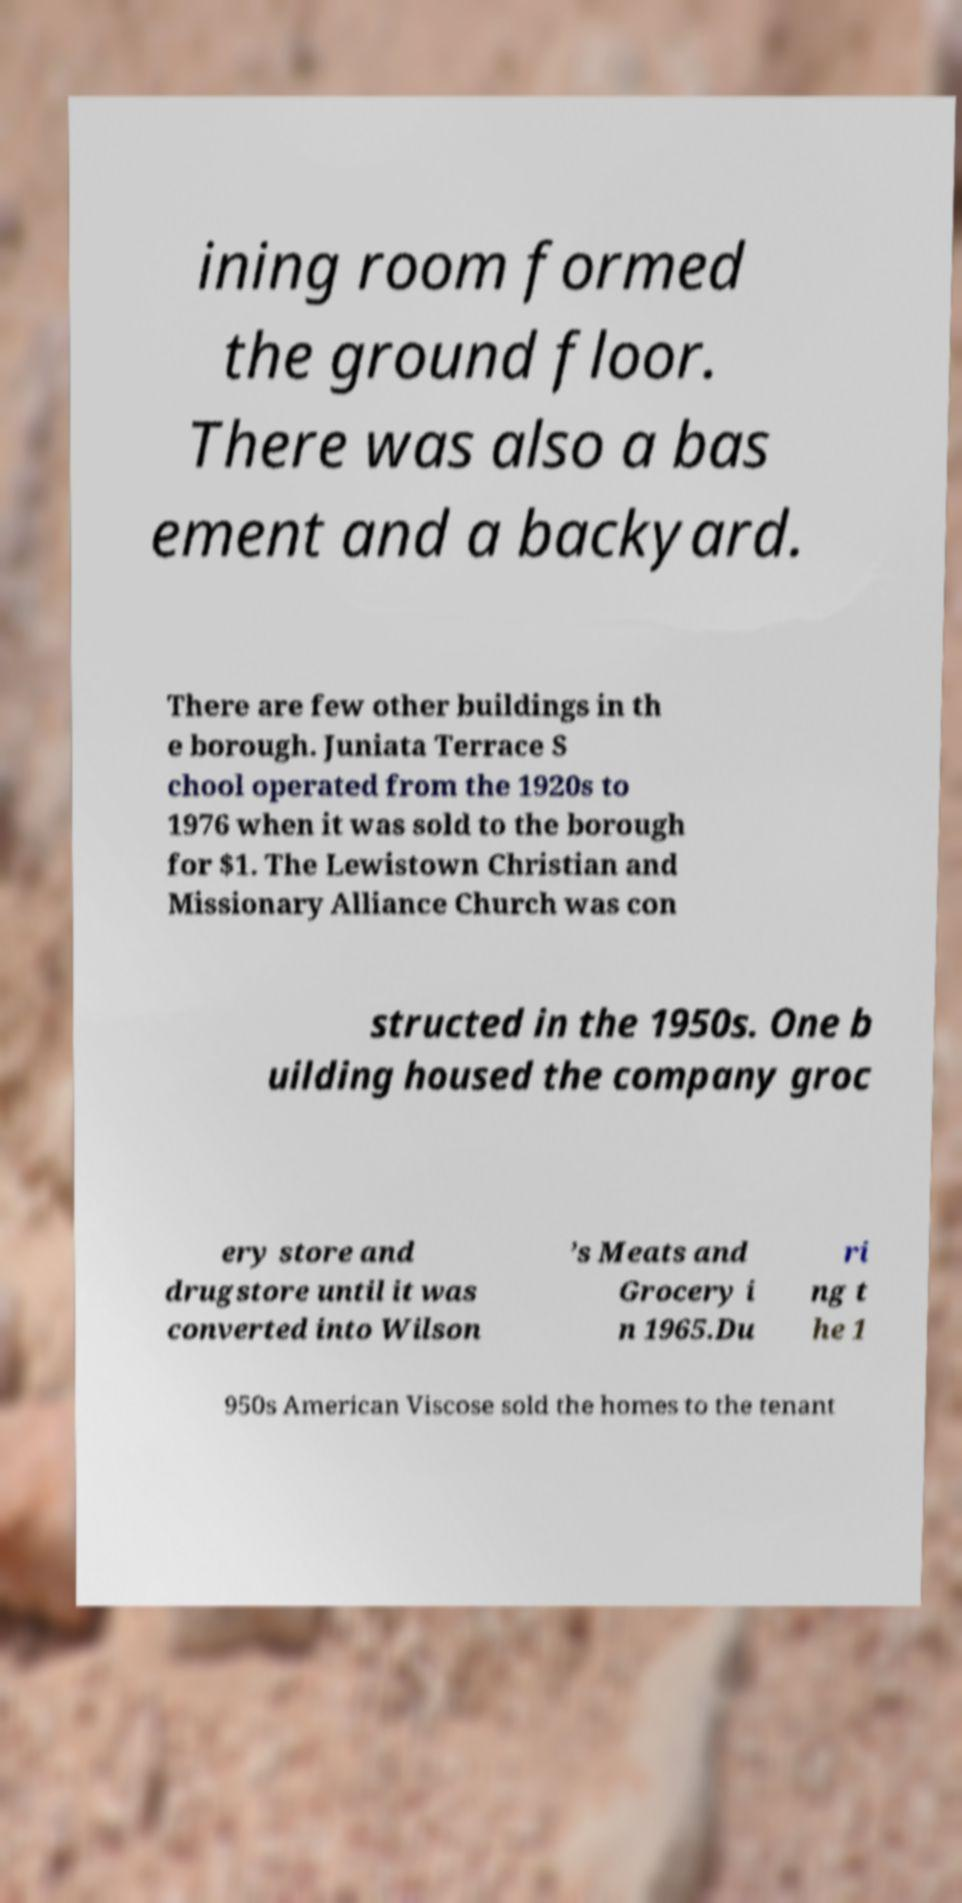I need the written content from this picture converted into text. Can you do that? ining room formed the ground floor. There was also a bas ement and a backyard. There are few other buildings in th e borough. Juniata Terrace S chool operated from the 1920s to 1976 when it was sold to the borough for $1. The Lewistown Christian and Missionary Alliance Church was con structed in the 1950s. One b uilding housed the company groc ery store and drugstore until it was converted into Wilson ’s Meats and Grocery i n 1965.Du ri ng t he 1 950s American Viscose sold the homes to the tenant 